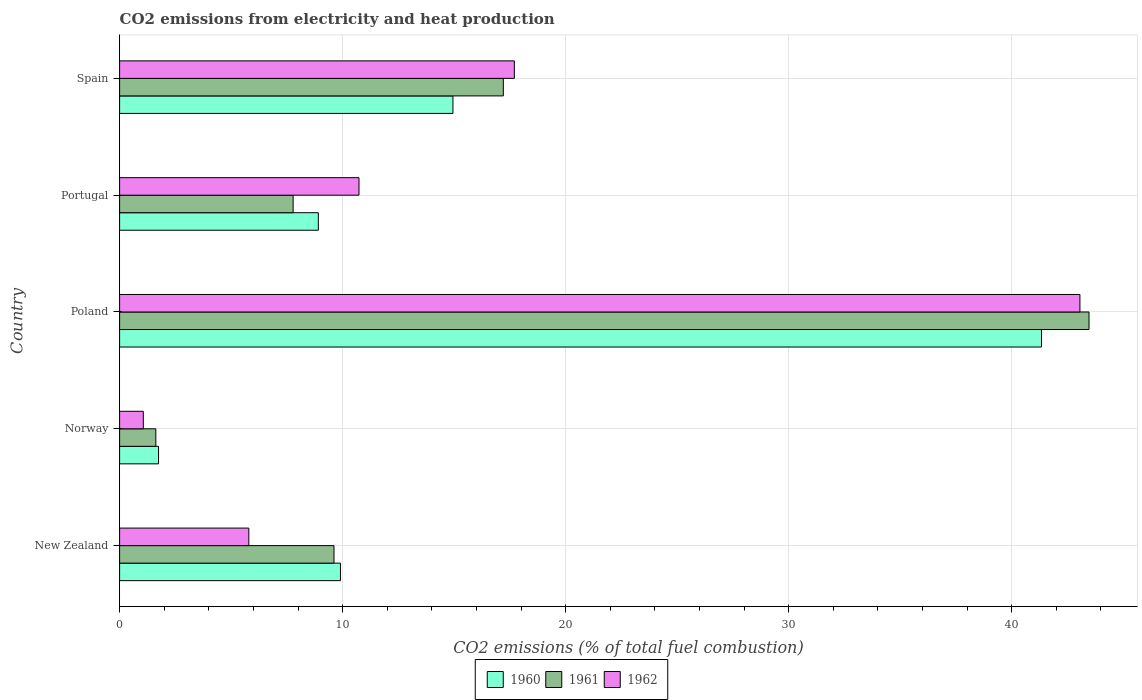How many different coloured bars are there?
Make the answer very short. 3. How many groups of bars are there?
Give a very brief answer. 5. Are the number of bars per tick equal to the number of legend labels?
Give a very brief answer. Yes. In how many cases, is the number of bars for a given country not equal to the number of legend labels?
Offer a very short reply. 0. What is the amount of CO2 emitted in 1962 in Portugal?
Ensure brevity in your answer.  10.73. Across all countries, what is the maximum amount of CO2 emitted in 1961?
Your response must be concise. 43.47. Across all countries, what is the minimum amount of CO2 emitted in 1960?
Ensure brevity in your answer.  1.75. In which country was the amount of CO2 emitted in 1960 minimum?
Your answer should be compact. Norway. What is the total amount of CO2 emitted in 1960 in the graph?
Your answer should be compact. 76.84. What is the difference between the amount of CO2 emitted in 1961 in Portugal and that in Spain?
Offer a terse response. -9.43. What is the difference between the amount of CO2 emitted in 1962 in New Zealand and the amount of CO2 emitted in 1960 in Norway?
Your answer should be very brief. 4.05. What is the average amount of CO2 emitted in 1960 per country?
Give a very brief answer. 15.37. What is the difference between the amount of CO2 emitted in 1961 and amount of CO2 emitted in 1962 in Poland?
Make the answer very short. 0.41. In how many countries, is the amount of CO2 emitted in 1960 greater than 18 %?
Make the answer very short. 1. What is the ratio of the amount of CO2 emitted in 1960 in Poland to that in Spain?
Make the answer very short. 2.77. Is the amount of CO2 emitted in 1962 in New Zealand less than that in Portugal?
Make the answer very short. Yes. Is the difference between the amount of CO2 emitted in 1961 in Norway and Poland greater than the difference between the amount of CO2 emitted in 1962 in Norway and Poland?
Your response must be concise. Yes. What is the difference between the highest and the second highest amount of CO2 emitted in 1960?
Ensure brevity in your answer.  26.39. What is the difference between the highest and the lowest amount of CO2 emitted in 1960?
Your answer should be very brief. 39.59. Is the sum of the amount of CO2 emitted in 1961 in New Zealand and Portugal greater than the maximum amount of CO2 emitted in 1962 across all countries?
Keep it short and to the point. No. How many bars are there?
Make the answer very short. 15. Are all the bars in the graph horizontal?
Your answer should be compact. Yes. Does the graph contain any zero values?
Give a very brief answer. No. Does the graph contain grids?
Your answer should be very brief. Yes. What is the title of the graph?
Offer a very short reply. CO2 emissions from electricity and heat production. What is the label or title of the X-axis?
Offer a terse response. CO2 emissions (% of total fuel combustion). What is the label or title of the Y-axis?
Offer a terse response. Country. What is the CO2 emissions (% of total fuel combustion) in 1960 in New Zealand?
Your answer should be compact. 9.9. What is the CO2 emissions (% of total fuel combustion) in 1961 in New Zealand?
Give a very brief answer. 9.61. What is the CO2 emissions (% of total fuel combustion) in 1962 in New Zealand?
Offer a terse response. 5.79. What is the CO2 emissions (% of total fuel combustion) in 1960 in Norway?
Offer a very short reply. 1.75. What is the CO2 emissions (% of total fuel combustion) of 1961 in Norway?
Offer a terse response. 1.63. What is the CO2 emissions (% of total fuel combustion) of 1962 in Norway?
Give a very brief answer. 1.06. What is the CO2 emissions (% of total fuel combustion) in 1960 in Poland?
Your response must be concise. 41.34. What is the CO2 emissions (% of total fuel combustion) of 1961 in Poland?
Provide a short and direct response. 43.47. What is the CO2 emissions (% of total fuel combustion) of 1962 in Poland?
Keep it short and to the point. 43.06. What is the CO2 emissions (% of total fuel combustion) of 1960 in Portugal?
Your answer should be compact. 8.91. What is the CO2 emissions (% of total fuel combustion) in 1961 in Portugal?
Provide a short and direct response. 7.78. What is the CO2 emissions (% of total fuel combustion) in 1962 in Portugal?
Ensure brevity in your answer.  10.73. What is the CO2 emissions (% of total fuel combustion) in 1960 in Spain?
Your response must be concise. 14.95. What is the CO2 emissions (% of total fuel combustion) of 1961 in Spain?
Your answer should be very brief. 17.21. What is the CO2 emissions (% of total fuel combustion) of 1962 in Spain?
Make the answer very short. 17.7. Across all countries, what is the maximum CO2 emissions (% of total fuel combustion) of 1960?
Ensure brevity in your answer.  41.34. Across all countries, what is the maximum CO2 emissions (% of total fuel combustion) in 1961?
Offer a terse response. 43.47. Across all countries, what is the maximum CO2 emissions (% of total fuel combustion) in 1962?
Your answer should be compact. 43.06. Across all countries, what is the minimum CO2 emissions (% of total fuel combustion) of 1960?
Offer a terse response. 1.75. Across all countries, what is the minimum CO2 emissions (% of total fuel combustion) of 1961?
Your response must be concise. 1.63. Across all countries, what is the minimum CO2 emissions (% of total fuel combustion) in 1962?
Provide a short and direct response. 1.06. What is the total CO2 emissions (% of total fuel combustion) of 1960 in the graph?
Keep it short and to the point. 76.84. What is the total CO2 emissions (% of total fuel combustion) in 1961 in the graph?
Keep it short and to the point. 79.7. What is the total CO2 emissions (% of total fuel combustion) in 1962 in the graph?
Keep it short and to the point. 78.35. What is the difference between the CO2 emissions (% of total fuel combustion) in 1960 in New Zealand and that in Norway?
Offer a very short reply. 8.16. What is the difference between the CO2 emissions (% of total fuel combustion) of 1961 in New Zealand and that in Norway?
Offer a very short reply. 7.99. What is the difference between the CO2 emissions (% of total fuel combustion) in 1962 in New Zealand and that in Norway?
Provide a short and direct response. 4.73. What is the difference between the CO2 emissions (% of total fuel combustion) of 1960 in New Zealand and that in Poland?
Offer a very short reply. -31.43. What is the difference between the CO2 emissions (% of total fuel combustion) in 1961 in New Zealand and that in Poland?
Make the answer very short. -33.86. What is the difference between the CO2 emissions (% of total fuel combustion) in 1962 in New Zealand and that in Poland?
Offer a very short reply. -37.27. What is the difference between the CO2 emissions (% of total fuel combustion) in 1961 in New Zealand and that in Portugal?
Your answer should be compact. 1.83. What is the difference between the CO2 emissions (% of total fuel combustion) of 1962 in New Zealand and that in Portugal?
Your response must be concise. -4.94. What is the difference between the CO2 emissions (% of total fuel combustion) in 1960 in New Zealand and that in Spain?
Your response must be concise. -5.04. What is the difference between the CO2 emissions (% of total fuel combustion) in 1961 in New Zealand and that in Spain?
Make the answer very short. -7.59. What is the difference between the CO2 emissions (% of total fuel combustion) of 1962 in New Zealand and that in Spain?
Provide a short and direct response. -11.91. What is the difference between the CO2 emissions (% of total fuel combustion) of 1960 in Norway and that in Poland?
Provide a short and direct response. -39.59. What is the difference between the CO2 emissions (% of total fuel combustion) in 1961 in Norway and that in Poland?
Offer a terse response. -41.84. What is the difference between the CO2 emissions (% of total fuel combustion) of 1962 in Norway and that in Poland?
Give a very brief answer. -42. What is the difference between the CO2 emissions (% of total fuel combustion) of 1960 in Norway and that in Portugal?
Your response must be concise. -7.16. What is the difference between the CO2 emissions (% of total fuel combustion) in 1961 in Norway and that in Portugal?
Give a very brief answer. -6.16. What is the difference between the CO2 emissions (% of total fuel combustion) of 1962 in Norway and that in Portugal?
Make the answer very short. -9.67. What is the difference between the CO2 emissions (% of total fuel combustion) of 1960 in Norway and that in Spain?
Keep it short and to the point. -13.2. What is the difference between the CO2 emissions (% of total fuel combustion) of 1961 in Norway and that in Spain?
Your response must be concise. -15.58. What is the difference between the CO2 emissions (% of total fuel combustion) of 1962 in Norway and that in Spain?
Keep it short and to the point. -16.64. What is the difference between the CO2 emissions (% of total fuel combustion) of 1960 in Poland and that in Portugal?
Keep it short and to the point. 32.43. What is the difference between the CO2 emissions (% of total fuel combustion) in 1961 in Poland and that in Portugal?
Provide a succinct answer. 35.69. What is the difference between the CO2 emissions (% of total fuel combustion) of 1962 in Poland and that in Portugal?
Your answer should be compact. 32.33. What is the difference between the CO2 emissions (% of total fuel combustion) in 1960 in Poland and that in Spain?
Your answer should be very brief. 26.39. What is the difference between the CO2 emissions (% of total fuel combustion) of 1961 in Poland and that in Spain?
Your answer should be compact. 26.26. What is the difference between the CO2 emissions (% of total fuel combustion) in 1962 in Poland and that in Spain?
Your answer should be compact. 25.36. What is the difference between the CO2 emissions (% of total fuel combustion) in 1960 in Portugal and that in Spain?
Give a very brief answer. -6.04. What is the difference between the CO2 emissions (% of total fuel combustion) in 1961 in Portugal and that in Spain?
Make the answer very short. -9.43. What is the difference between the CO2 emissions (% of total fuel combustion) of 1962 in Portugal and that in Spain?
Make the answer very short. -6.97. What is the difference between the CO2 emissions (% of total fuel combustion) of 1960 in New Zealand and the CO2 emissions (% of total fuel combustion) of 1961 in Norway?
Give a very brief answer. 8.28. What is the difference between the CO2 emissions (% of total fuel combustion) in 1960 in New Zealand and the CO2 emissions (% of total fuel combustion) in 1962 in Norway?
Make the answer very short. 8.84. What is the difference between the CO2 emissions (% of total fuel combustion) of 1961 in New Zealand and the CO2 emissions (% of total fuel combustion) of 1962 in Norway?
Your answer should be compact. 8.55. What is the difference between the CO2 emissions (% of total fuel combustion) of 1960 in New Zealand and the CO2 emissions (% of total fuel combustion) of 1961 in Poland?
Your answer should be very brief. -33.57. What is the difference between the CO2 emissions (% of total fuel combustion) in 1960 in New Zealand and the CO2 emissions (% of total fuel combustion) in 1962 in Poland?
Ensure brevity in your answer.  -33.16. What is the difference between the CO2 emissions (% of total fuel combustion) in 1961 in New Zealand and the CO2 emissions (% of total fuel combustion) in 1962 in Poland?
Ensure brevity in your answer.  -33.45. What is the difference between the CO2 emissions (% of total fuel combustion) of 1960 in New Zealand and the CO2 emissions (% of total fuel combustion) of 1961 in Portugal?
Make the answer very short. 2.12. What is the difference between the CO2 emissions (% of total fuel combustion) of 1960 in New Zealand and the CO2 emissions (% of total fuel combustion) of 1962 in Portugal?
Ensure brevity in your answer.  -0.83. What is the difference between the CO2 emissions (% of total fuel combustion) of 1961 in New Zealand and the CO2 emissions (% of total fuel combustion) of 1962 in Portugal?
Keep it short and to the point. -1.12. What is the difference between the CO2 emissions (% of total fuel combustion) of 1960 in New Zealand and the CO2 emissions (% of total fuel combustion) of 1961 in Spain?
Provide a short and direct response. -7.3. What is the difference between the CO2 emissions (% of total fuel combustion) of 1960 in New Zealand and the CO2 emissions (% of total fuel combustion) of 1962 in Spain?
Provide a succinct answer. -7.8. What is the difference between the CO2 emissions (% of total fuel combustion) in 1961 in New Zealand and the CO2 emissions (% of total fuel combustion) in 1962 in Spain?
Provide a succinct answer. -8.09. What is the difference between the CO2 emissions (% of total fuel combustion) in 1960 in Norway and the CO2 emissions (% of total fuel combustion) in 1961 in Poland?
Keep it short and to the point. -41.72. What is the difference between the CO2 emissions (% of total fuel combustion) of 1960 in Norway and the CO2 emissions (% of total fuel combustion) of 1962 in Poland?
Your answer should be compact. -41.31. What is the difference between the CO2 emissions (% of total fuel combustion) of 1961 in Norway and the CO2 emissions (% of total fuel combustion) of 1962 in Poland?
Give a very brief answer. -41.44. What is the difference between the CO2 emissions (% of total fuel combustion) in 1960 in Norway and the CO2 emissions (% of total fuel combustion) in 1961 in Portugal?
Ensure brevity in your answer.  -6.03. What is the difference between the CO2 emissions (% of total fuel combustion) in 1960 in Norway and the CO2 emissions (% of total fuel combustion) in 1962 in Portugal?
Provide a short and direct response. -8.99. What is the difference between the CO2 emissions (% of total fuel combustion) in 1961 in Norway and the CO2 emissions (% of total fuel combustion) in 1962 in Portugal?
Keep it short and to the point. -9.11. What is the difference between the CO2 emissions (% of total fuel combustion) of 1960 in Norway and the CO2 emissions (% of total fuel combustion) of 1961 in Spain?
Your response must be concise. -15.46. What is the difference between the CO2 emissions (% of total fuel combustion) of 1960 in Norway and the CO2 emissions (% of total fuel combustion) of 1962 in Spain?
Provide a short and direct response. -15.95. What is the difference between the CO2 emissions (% of total fuel combustion) of 1961 in Norway and the CO2 emissions (% of total fuel combustion) of 1962 in Spain?
Provide a succinct answer. -16.08. What is the difference between the CO2 emissions (% of total fuel combustion) in 1960 in Poland and the CO2 emissions (% of total fuel combustion) in 1961 in Portugal?
Provide a succinct answer. 33.56. What is the difference between the CO2 emissions (% of total fuel combustion) in 1960 in Poland and the CO2 emissions (% of total fuel combustion) in 1962 in Portugal?
Ensure brevity in your answer.  30.6. What is the difference between the CO2 emissions (% of total fuel combustion) of 1961 in Poland and the CO2 emissions (% of total fuel combustion) of 1962 in Portugal?
Offer a terse response. 32.73. What is the difference between the CO2 emissions (% of total fuel combustion) of 1960 in Poland and the CO2 emissions (% of total fuel combustion) of 1961 in Spain?
Offer a very short reply. 24.13. What is the difference between the CO2 emissions (% of total fuel combustion) of 1960 in Poland and the CO2 emissions (% of total fuel combustion) of 1962 in Spain?
Provide a succinct answer. 23.64. What is the difference between the CO2 emissions (% of total fuel combustion) in 1961 in Poland and the CO2 emissions (% of total fuel combustion) in 1962 in Spain?
Ensure brevity in your answer.  25.77. What is the difference between the CO2 emissions (% of total fuel combustion) in 1960 in Portugal and the CO2 emissions (% of total fuel combustion) in 1961 in Spain?
Provide a short and direct response. -8.3. What is the difference between the CO2 emissions (% of total fuel combustion) of 1960 in Portugal and the CO2 emissions (% of total fuel combustion) of 1962 in Spain?
Make the answer very short. -8.79. What is the difference between the CO2 emissions (% of total fuel combustion) of 1961 in Portugal and the CO2 emissions (% of total fuel combustion) of 1962 in Spain?
Make the answer very short. -9.92. What is the average CO2 emissions (% of total fuel combustion) of 1960 per country?
Ensure brevity in your answer.  15.37. What is the average CO2 emissions (% of total fuel combustion) in 1961 per country?
Offer a very short reply. 15.94. What is the average CO2 emissions (% of total fuel combustion) in 1962 per country?
Keep it short and to the point. 15.67. What is the difference between the CO2 emissions (% of total fuel combustion) of 1960 and CO2 emissions (% of total fuel combustion) of 1961 in New Zealand?
Offer a terse response. 0.29. What is the difference between the CO2 emissions (% of total fuel combustion) in 1960 and CO2 emissions (% of total fuel combustion) in 1962 in New Zealand?
Offer a terse response. 4.11. What is the difference between the CO2 emissions (% of total fuel combustion) of 1961 and CO2 emissions (% of total fuel combustion) of 1962 in New Zealand?
Provide a succinct answer. 3.82. What is the difference between the CO2 emissions (% of total fuel combustion) of 1960 and CO2 emissions (% of total fuel combustion) of 1961 in Norway?
Give a very brief answer. 0.12. What is the difference between the CO2 emissions (% of total fuel combustion) of 1960 and CO2 emissions (% of total fuel combustion) of 1962 in Norway?
Your answer should be very brief. 0.68. What is the difference between the CO2 emissions (% of total fuel combustion) of 1961 and CO2 emissions (% of total fuel combustion) of 1962 in Norway?
Make the answer very short. 0.56. What is the difference between the CO2 emissions (% of total fuel combustion) in 1960 and CO2 emissions (% of total fuel combustion) in 1961 in Poland?
Provide a succinct answer. -2.13. What is the difference between the CO2 emissions (% of total fuel combustion) in 1960 and CO2 emissions (% of total fuel combustion) in 1962 in Poland?
Keep it short and to the point. -1.72. What is the difference between the CO2 emissions (% of total fuel combustion) in 1961 and CO2 emissions (% of total fuel combustion) in 1962 in Poland?
Your response must be concise. 0.41. What is the difference between the CO2 emissions (% of total fuel combustion) of 1960 and CO2 emissions (% of total fuel combustion) of 1961 in Portugal?
Offer a terse response. 1.13. What is the difference between the CO2 emissions (% of total fuel combustion) of 1960 and CO2 emissions (% of total fuel combustion) of 1962 in Portugal?
Provide a short and direct response. -1.82. What is the difference between the CO2 emissions (% of total fuel combustion) in 1961 and CO2 emissions (% of total fuel combustion) in 1962 in Portugal?
Make the answer very short. -2.95. What is the difference between the CO2 emissions (% of total fuel combustion) of 1960 and CO2 emissions (% of total fuel combustion) of 1961 in Spain?
Offer a terse response. -2.26. What is the difference between the CO2 emissions (% of total fuel combustion) of 1960 and CO2 emissions (% of total fuel combustion) of 1962 in Spain?
Ensure brevity in your answer.  -2.75. What is the difference between the CO2 emissions (% of total fuel combustion) of 1961 and CO2 emissions (% of total fuel combustion) of 1962 in Spain?
Provide a short and direct response. -0.49. What is the ratio of the CO2 emissions (% of total fuel combustion) of 1960 in New Zealand to that in Norway?
Your response must be concise. 5.67. What is the ratio of the CO2 emissions (% of total fuel combustion) of 1961 in New Zealand to that in Norway?
Provide a succinct answer. 5.91. What is the ratio of the CO2 emissions (% of total fuel combustion) in 1962 in New Zealand to that in Norway?
Your response must be concise. 5.45. What is the ratio of the CO2 emissions (% of total fuel combustion) of 1960 in New Zealand to that in Poland?
Keep it short and to the point. 0.24. What is the ratio of the CO2 emissions (% of total fuel combustion) of 1961 in New Zealand to that in Poland?
Make the answer very short. 0.22. What is the ratio of the CO2 emissions (% of total fuel combustion) of 1962 in New Zealand to that in Poland?
Give a very brief answer. 0.13. What is the ratio of the CO2 emissions (% of total fuel combustion) in 1960 in New Zealand to that in Portugal?
Give a very brief answer. 1.11. What is the ratio of the CO2 emissions (% of total fuel combustion) in 1961 in New Zealand to that in Portugal?
Provide a succinct answer. 1.24. What is the ratio of the CO2 emissions (% of total fuel combustion) in 1962 in New Zealand to that in Portugal?
Give a very brief answer. 0.54. What is the ratio of the CO2 emissions (% of total fuel combustion) in 1960 in New Zealand to that in Spain?
Provide a succinct answer. 0.66. What is the ratio of the CO2 emissions (% of total fuel combustion) of 1961 in New Zealand to that in Spain?
Your answer should be very brief. 0.56. What is the ratio of the CO2 emissions (% of total fuel combustion) in 1962 in New Zealand to that in Spain?
Keep it short and to the point. 0.33. What is the ratio of the CO2 emissions (% of total fuel combustion) of 1960 in Norway to that in Poland?
Make the answer very short. 0.04. What is the ratio of the CO2 emissions (% of total fuel combustion) of 1961 in Norway to that in Poland?
Provide a succinct answer. 0.04. What is the ratio of the CO2 emissions (% of total fuel combustion) of 1962 in Norway to that in Poland?
Your response must be concise. 0.02. What is the ratio of the CO2 emissions (% of total fuel combustion) in 1960 in Norway to that in Portugal?
Ensure brevity in your answer.  0.2. What is the ratio of the CO2 emissions (% of total fuel combustion) of 1961 in Norway to that in Portugal?
Give a very brief answer. 0.21. What is the ratio of the CO2 emissions (% of total fuel combustion) of 1962 in Norway to that in Portugal?
Your answer should be very brief. 0.1. What is the ratio of the CO2 emissions (% of total fuel combustion) of 1960 in Norway to that in Spain?
Ensure brevity in your answer.  0.12. What is the ratio of the CO2 emissions (% of total fuel combustion) in 1961 in Norway to that in Spain?
Provide a succinct answer. 0.09. What is the ratio of the CO2 emissions (% of total fuel combustion) of 1962 in Norway to that in Spain?
Keep it short and to the point. 0.06. What is the ratio of the CO2 emissions (% of total fuel combustion) in 1960 in Poland to that in Portugal?
Provide a succinct answer. 4.64. What is the ratio of the CO2 emissions (% of total fuel combustion) in 1961 in Poland to that in Portugal?
Ensure brevity in your answer.  5.59. What is the ratio of the CO2 emissions (% of total fuel combustion) in 1962 in Poland to that in Portugal?
Offer a very short reply. 4.01. What is the ratio of the CO2 emissions (% of total fuel combustion) in 1960 in Poland to that in Spain?
Provide a succinct answer. 2.77. What is the ratio of the CO2 emissions (% of total fuel combustion) of 1961 in Poland to that in Spain?
Your answer should be compact. 2.53. What is the ratio of the CO2 emissions (% of total fuel combustion) of 1962 in Poland to that in Spain?
Your answer should be compact. 2.43. What is the ratio of the CO2 emissions (% of total fuel combustion) in 1960 in Portugal to that in Spain?
Your response must be concise. 0.6. What is the ratio of the CO2 emissions (% of total fuel combustion) of 1961 in Portugal to that in Spain?
Make the answer very short. 0.45. What is the ratio of the CO2 emissions (% of total fuel combustion) of 1962 in Portugal to that in Spain?
Your response must be concise. 0.61. What is the difference between the highest and the second highest CO2 emissions (% of total fuel combustion) in 1960?
Your response must be concise. 26.39. What is the difference between the highest and the second highest CO2 emissions (% of total fuel combustion) in 1961?
Your answer should be compact. 26.26. What is the difference between the highest and the second highest CO2 emissions (% of total fuel combustion) of 1962?
Provide a short and direct response. 25.36. What is the difference between the highest and the lowest CO2 emissions (% of total fuel combustion) in 1960?
Your answer should be very brief. 39.59. What is the difference between the highest and the lowest CO2 emissions (% of total fuel combustion) in 1961?
Keep it short and to the point. 41.84. What is the difference between the highest and the lowest CO2 emissions (% of total fuel combustion) in 1962?
Give a very brief answer. 42. 